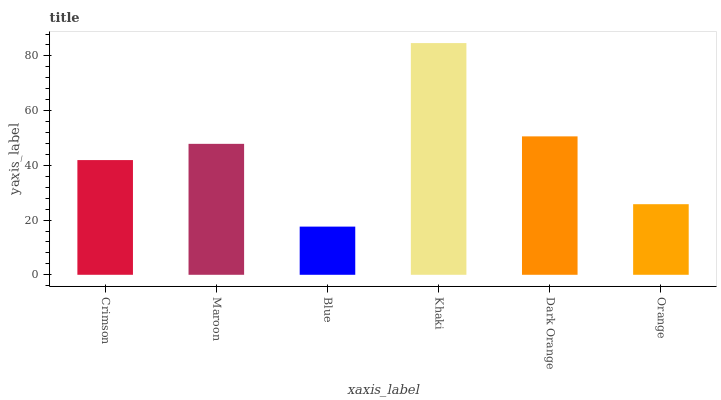Is Blue the minimum?
Answer yes or no. Yes. Is Khaki the maximum?
Answer yes or no. Yes. Is Maroon the minimum?
Answer yes or no. No. Is Maroon the maximum?
Answer yes or no. No. Is Maroon greater than Crimson?
Answer yes or no. Yes. Is Crimson less than Maroon?
Answer yes or no. Yes. Is Crimson greater than Maroon?
Answer yes or no. No. Is Maroon less than Crimson?
Answer yes or no. No. Is Maroon the high median?
Answer yes or no. Yes. Is Crimson the low median?
Answer yes or no. Yes. Is Crimson the high median?
Answer yes or no. No. Is Orange the low median?
Answer yes or no. No. 